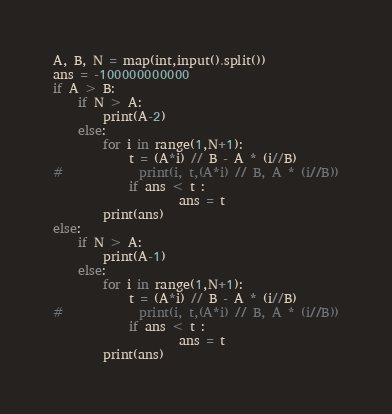<code> <loc_0><loc_0><loc_500><loc_500><_Python_>A, B, N = map(int,input().split())
ans = -100000000000
if A > B:
    if N > A:
        print(A-2)
    else:
        for i in range(1,N+1):
            t = (A*i) // B - A * (i//B)
#            print(i, t,(A*i) // B, A * (i//B))
            if ans < t :
                    ans = t
        print(ans)
else:
    if N > A:
        print(A-1)
    else:
        for i in range(1,N+1):
            t = (A*i) // B - A * (i//B)
#            print(i, t,(A*i) // B, A * (i//B))
            if ans < t :
                    ans = t
        print(ans)</code> 